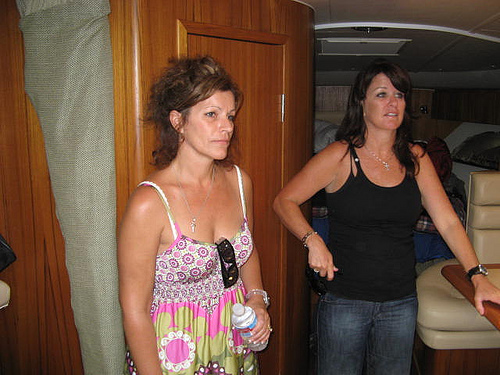<image>
Can you confirm if the sunglasses is on the lady? No. The sunglasses is not positioned on the lady. They may be near each other, but the sunglasses is not supported by or resting on top of the lady. Where is the black shirt in relation to the flower dress? Is it in front of the flower dress? No. The black shirt is not in front of the flower dress. The spatial positioning shows a different relationship between these objects. 